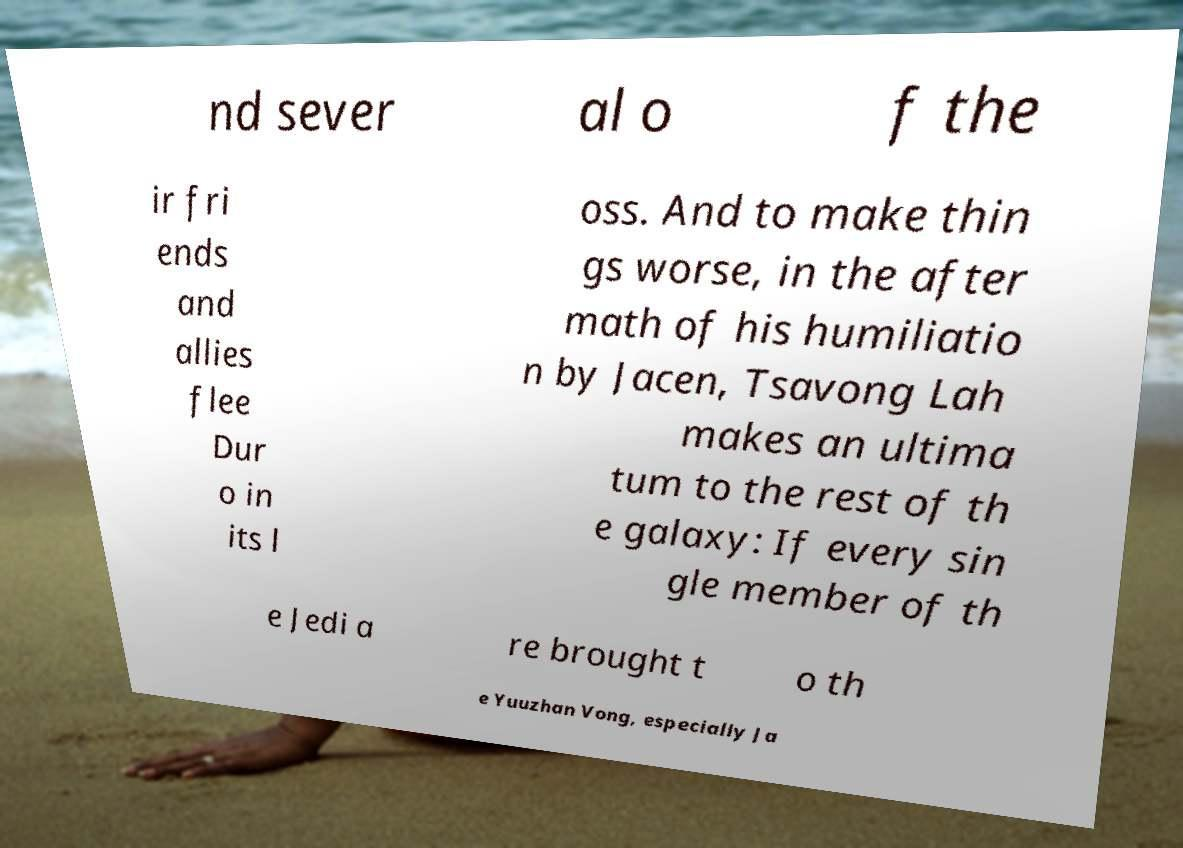Could you extract and type out the text from this image? nd sever al o f the ir fri ends and allies flee Dur o in its l oss. And to make thin gs worse, in the after math of his humiliatio n by Jacen, Tsavong Lah makes an ultima tum to the rest of th e galaxy: If every sin gle member of th e Jedi a re brought t o th e Yuuzhan Vong, especially Ja 